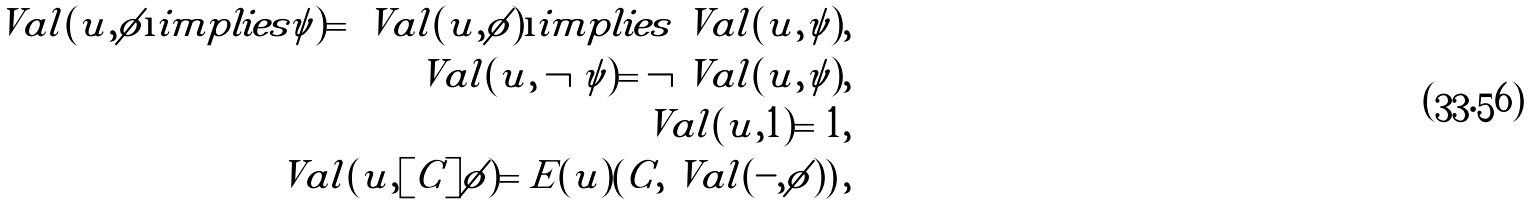Convert formula to latex. <formula><loc_0><loc_0><loc_500><loc_500>\ V a l ( u , \phi \i i m p l i e s \psi ) = \ V a l ( u , \phi ) \i i m p l i e s \ V a l ( u , \psi ) , \\ \ V a l ( u , \neg \psi ) = \neg \ V a l ( u , \psi ) , \\ \ V a l ( u , 1 ) = 1 , \\ \ V a l ( u , [ C ] \phi ) = E ( u ) \left ( C , \ V a l ( - , \phi ) \right ) ,</formula> 